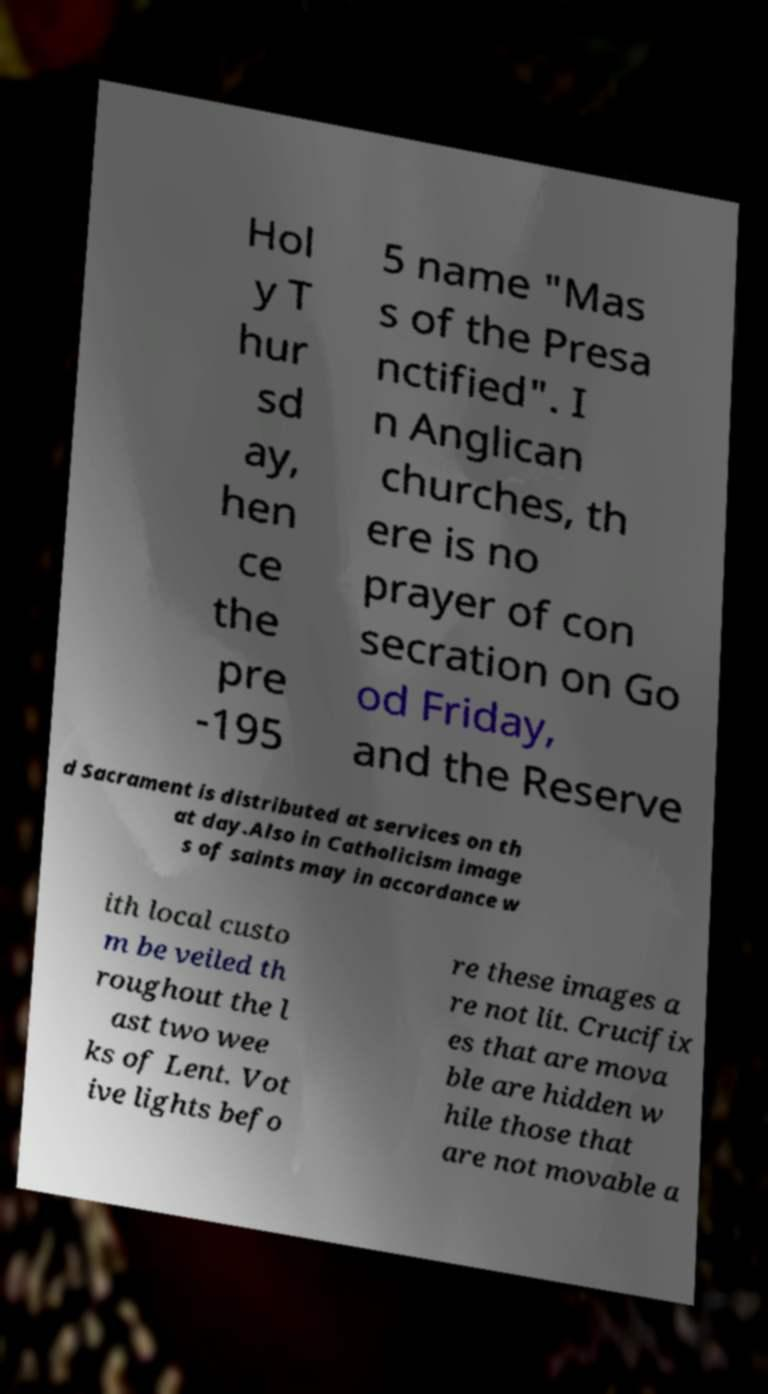What messages or text are displayed in this image? I need them in a readable, typed format. Hol y T hur sd ay, hen ce the pre -195 5 name "Mas s of the Presa nctified". I n Anglican churches, th ere is no prayer of con secration on Go od Friday, and the Reserve d Sacrament is distributed at services on th at day.Also in Catholicism image s of saints may in accordance w ith local custo m be veiled th roughout the l ast two wee ks of Lent. Vot ive lights befo re these images a re not lit. Crucifix es that are mova ble are hidden w hile those that are not movable a 